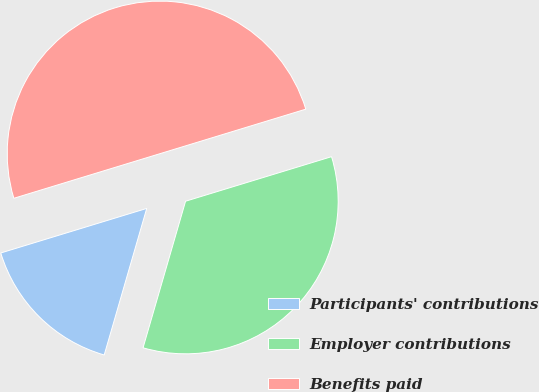Convert chart. <chart><loc_0><loc_0><loc_500><loc_500><pie_chart><fcel>Participants' contributions<fcel>Employer contributions<fcel>Benefits paid<nl><fcel>15.79%<fcel>34.21%<fcel>50.0%<nl></chart> 